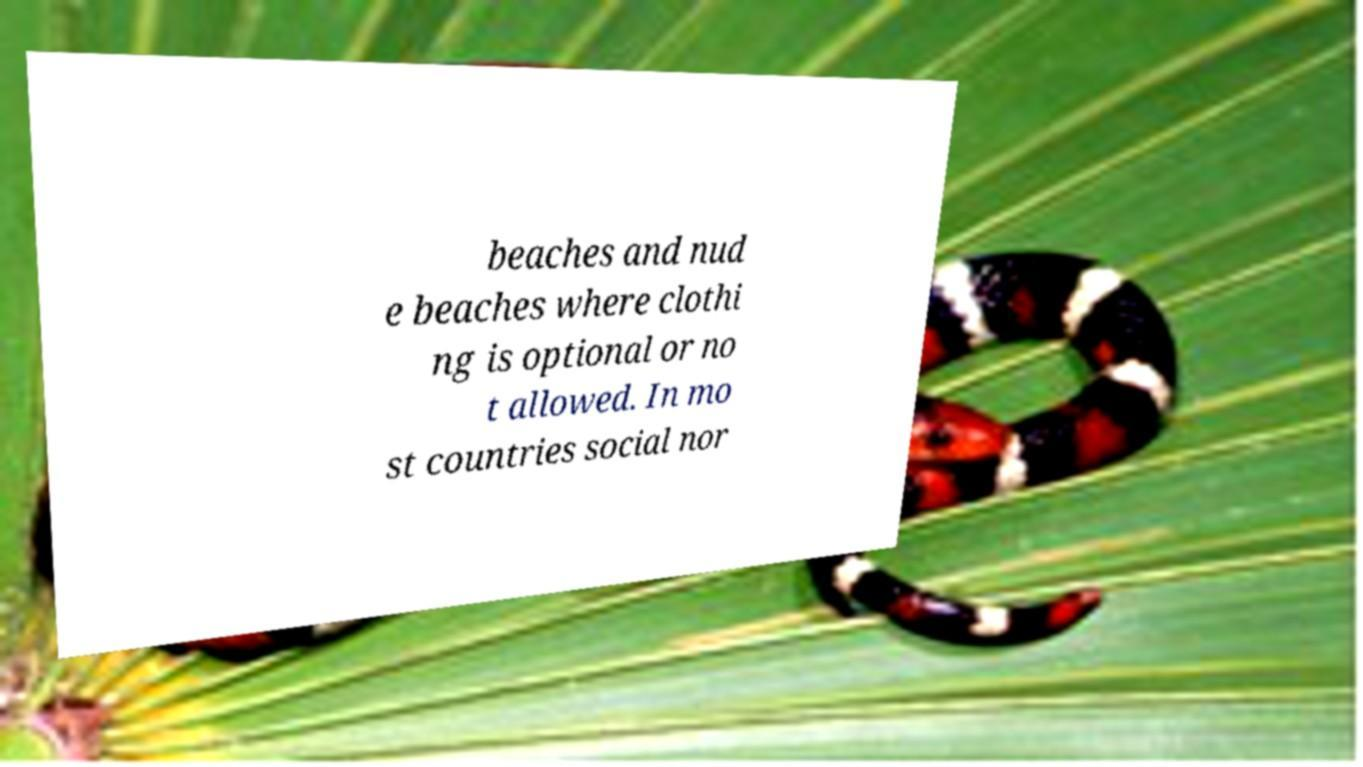I need the written content from this picture converted into text. Can you do that? beaches and nud e beaches where clothi ng is optional or no t allowed. In mo st countries social nor 